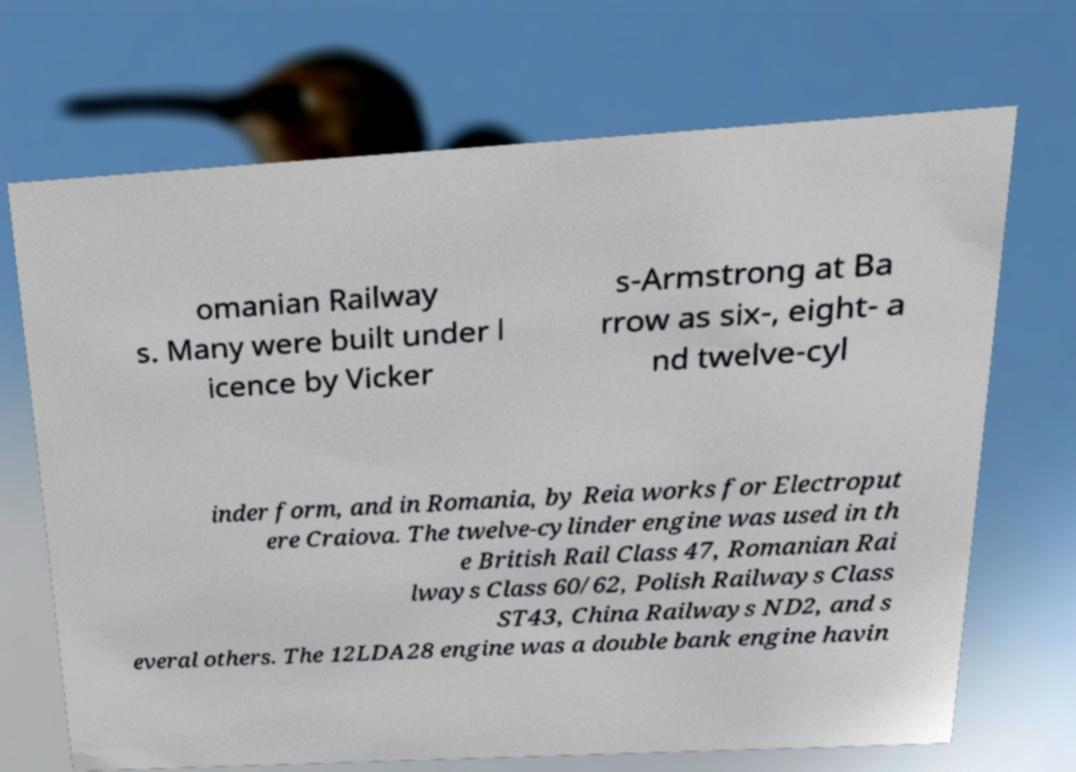Can you accurately transcribe the text from the provided image for me? omanian Railway s. Many were built under l icence by Vicker s-Armstrong at Ba rrow as six-, eight- a nd twelve-cyl inder form, and in Romania, by Reia works for Electroput ere Craiova. The twelve-cylinder engine was used in th e British Rail Class 47, Romanian Rai lways Class 60/62, Polish Railways Class ST43, China Railways ND2, and s everal others. The 12LDA28 engine was a double bank engine havin 